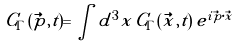Convert formula to latex. <formula><loc_0><loc_0><loc_500><loc_500>C _ { \Gamma } ( \vec { p } , t ) = \int d ^ { 3 } x \, C _ { \Gamma } ( \vec { x } , t ) \, e ^ { i \vec { p } \cdot \vec { x } }</formula> 